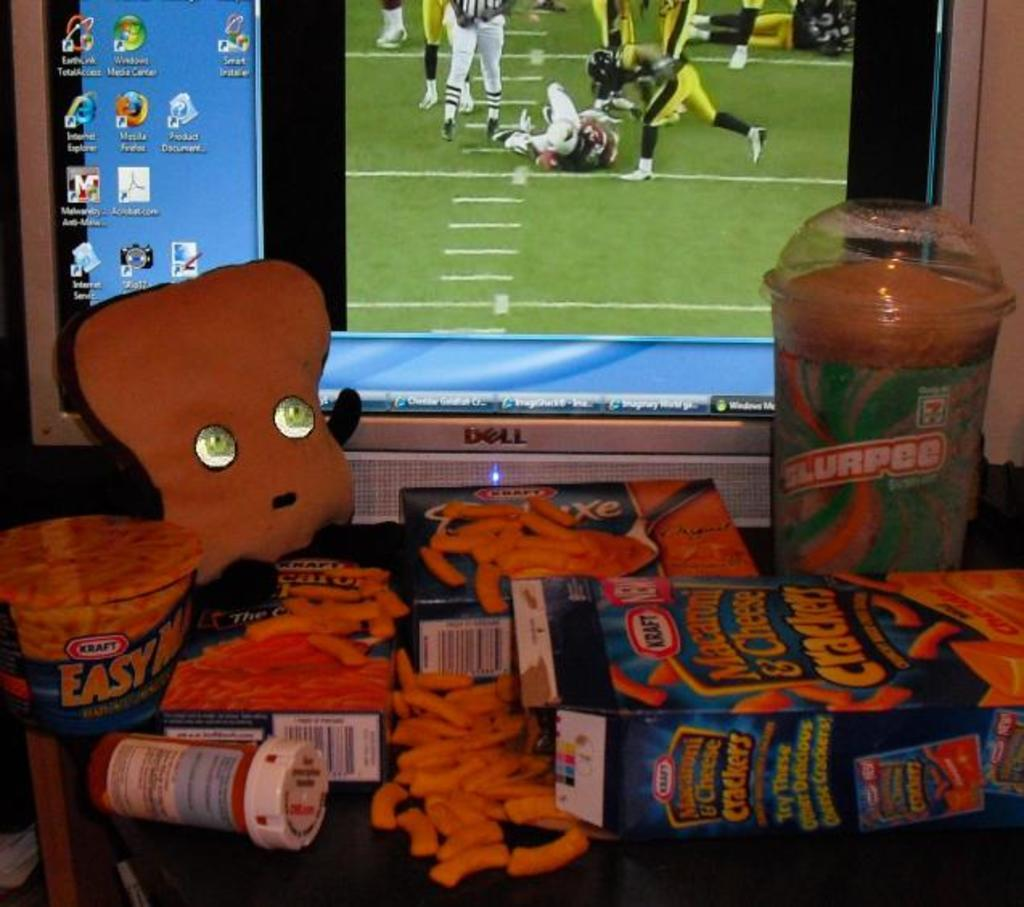<image>
Offer a succinct explanation of the picture presented. Boxes of Kraft mac'n cheese are in front of a computer monitor. 